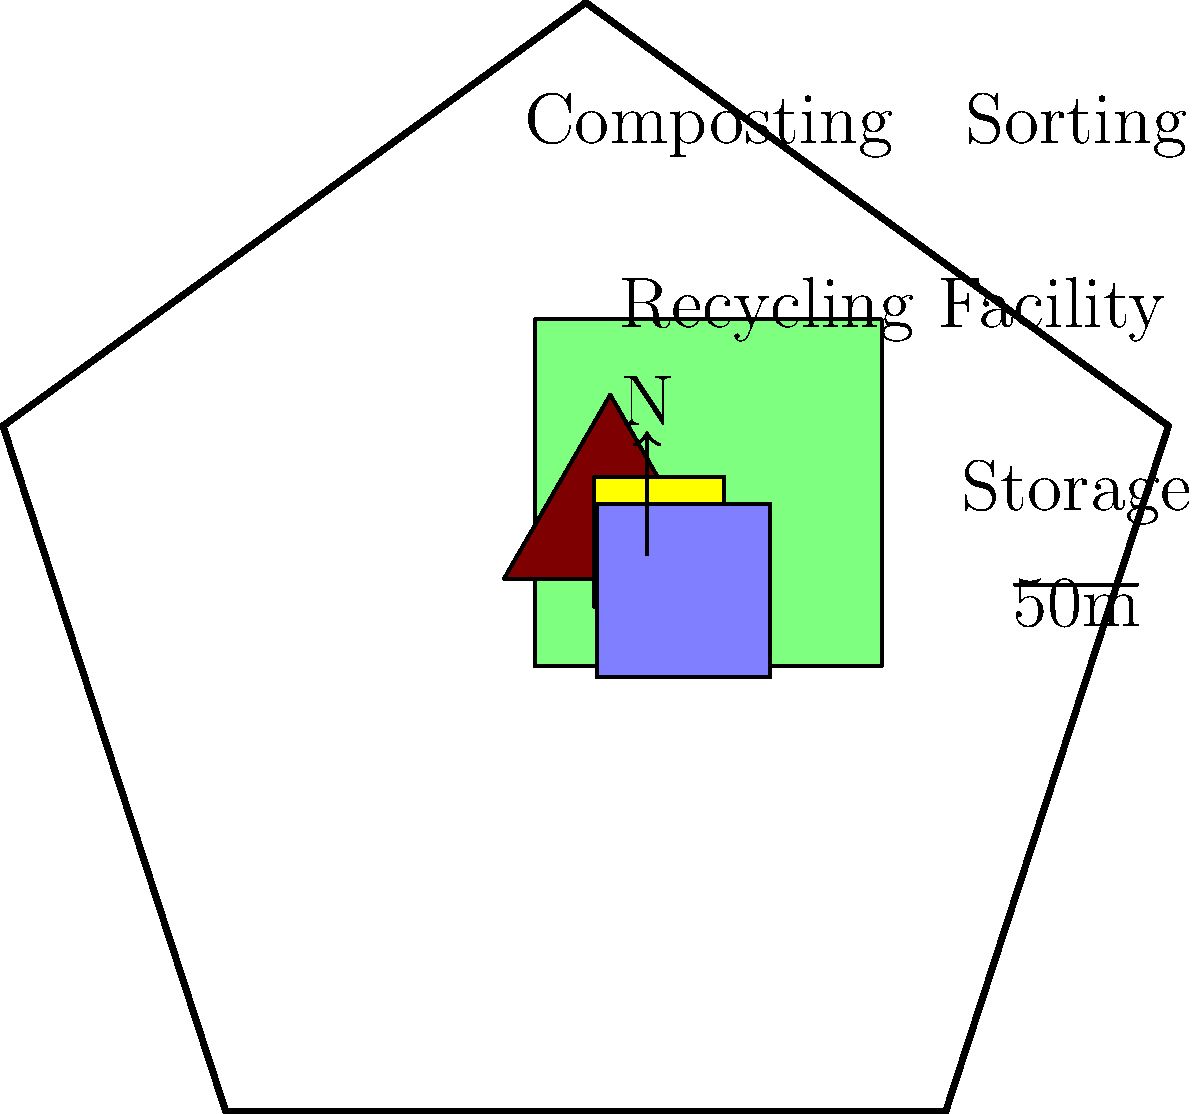Based on the site plan for a waste management and recycling facility, which area is strategically placed to minimize transportation distance between initial waste sorting and final storage, potentially reducing the facility's carbon footprint? To answer this question, we need to analyze the layout of the waste management and recycling facility with an environmentalist's perspective. Let's break it down step-by-step:

1. Identify the key areas in the site plan:
   - Recycling Facility (center, largest area)
   - Composting area (top left)
   - Sorting area (top right)
   - Storage area (bottom right)

2. Consider the typical waste management process:
   a. Waste arrives at the facility
   b. Initial sorting takes place
   c. Recyclables are processed
   d. Non-recyclables and processed materials are stored

3. Analyze the relative positions of the sorting and storage areas:
   - The sorting area is located in the top right corner
   - The storage area is located in the bottom right corner
   - These two areas are adjacent to each other

4. Evaluate the benefits of this arrangement:
   - Minimizes the distance between sorting and storage
   - Reduces transportation time and energy use
   - Potentially lowers the carbon footprint of the facility

5. Consider alternative layouts:
   - If sorting and storage were on opposite sides of the facility, it would increase transportation distance and energy use

6. Conclude that the current layout is optimized for efficiency and reduced environmental impact, aligning with environmentalist principles.
Answer: Sorting area 